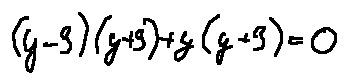<formula> <loc_0><loc_0><loc_500><loc_500>( y - 3 ) ( y + 3 ) + y ( y + 3 ) = 0</formula> 